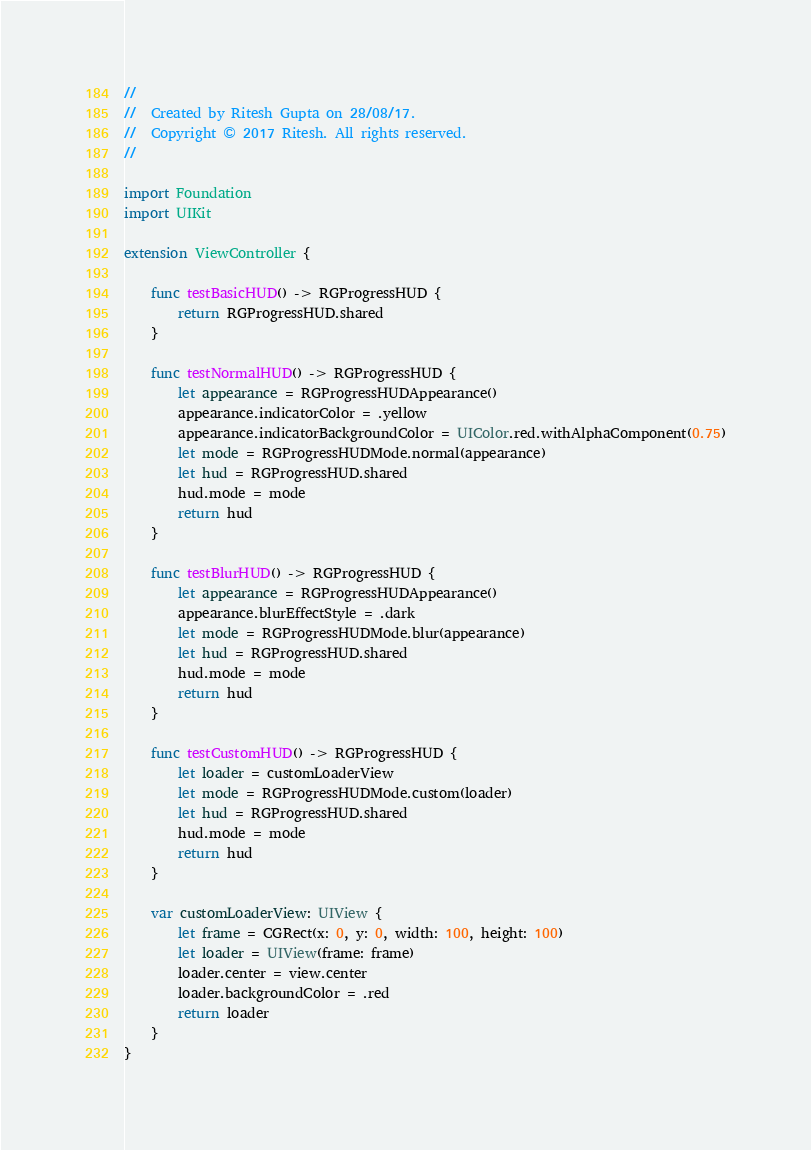<code> <loc_0><loc_0><loc_500><loc_500><_Swift_>//
//  Created by Ritesh Gupta on 28/08/17.
//  Copyright © 2017 Ritesh. All rights reserved.
//

import Foundation
import UIKit

extension ViewController {

	func testBasicHUD() -> RGProgressHUD {
		return RGProgressHUD.shared
	}

	func testNormalHUD() -> RGProgressHUD {
		let appearance = RGProgressHUDAppearance()
		appearance.indicatorColor = .yellow
		appearance.indicatorBackgroundColor = UIColor.red.withAlphaComponent(0.75)
		let mode = RGProgressHUDMode.normal(appearance)
		let hud = RGProgressHUD.shared
		hud.mode = mode
		return hud
	}

	func testBlurHUD() -> RGProgressHUD {
		let appearance = RGProgressHUDAppearance()
		appearance.blurEffectStyle = .dark
		let mode = RGProgressHUDMode.blur(appearance)
		let hud = RGProgressHUD.shared
		hud.mode = mode
		return hud
	}

	func testCustomHUD() -> RGProgressHUD {
		let loader = customLoaderView
		let mode = RGProgressHUDMode.custom(loader)
		let hud = RGProgressHUD.shared
		hud.mode = mode
		return hud
	}

	var customLoaderView: UIView {
		let frame = CGRect(x: 0, y: 0, width: 100, height: 100)
		let loader = UIView(frame: frame)
		loader.center = view.center
		loader.backgroundColor = .red
		return loader
	}
}
</code> 